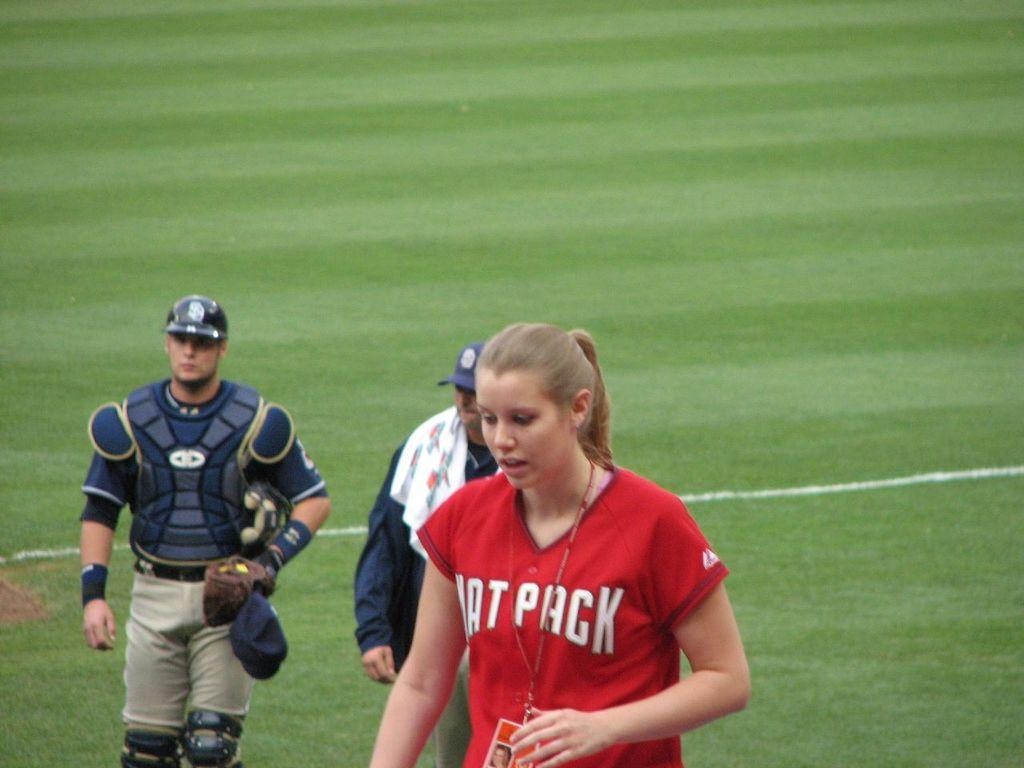<image>
Describe the image concisely. a lady that has a baseball jersey that says pack 